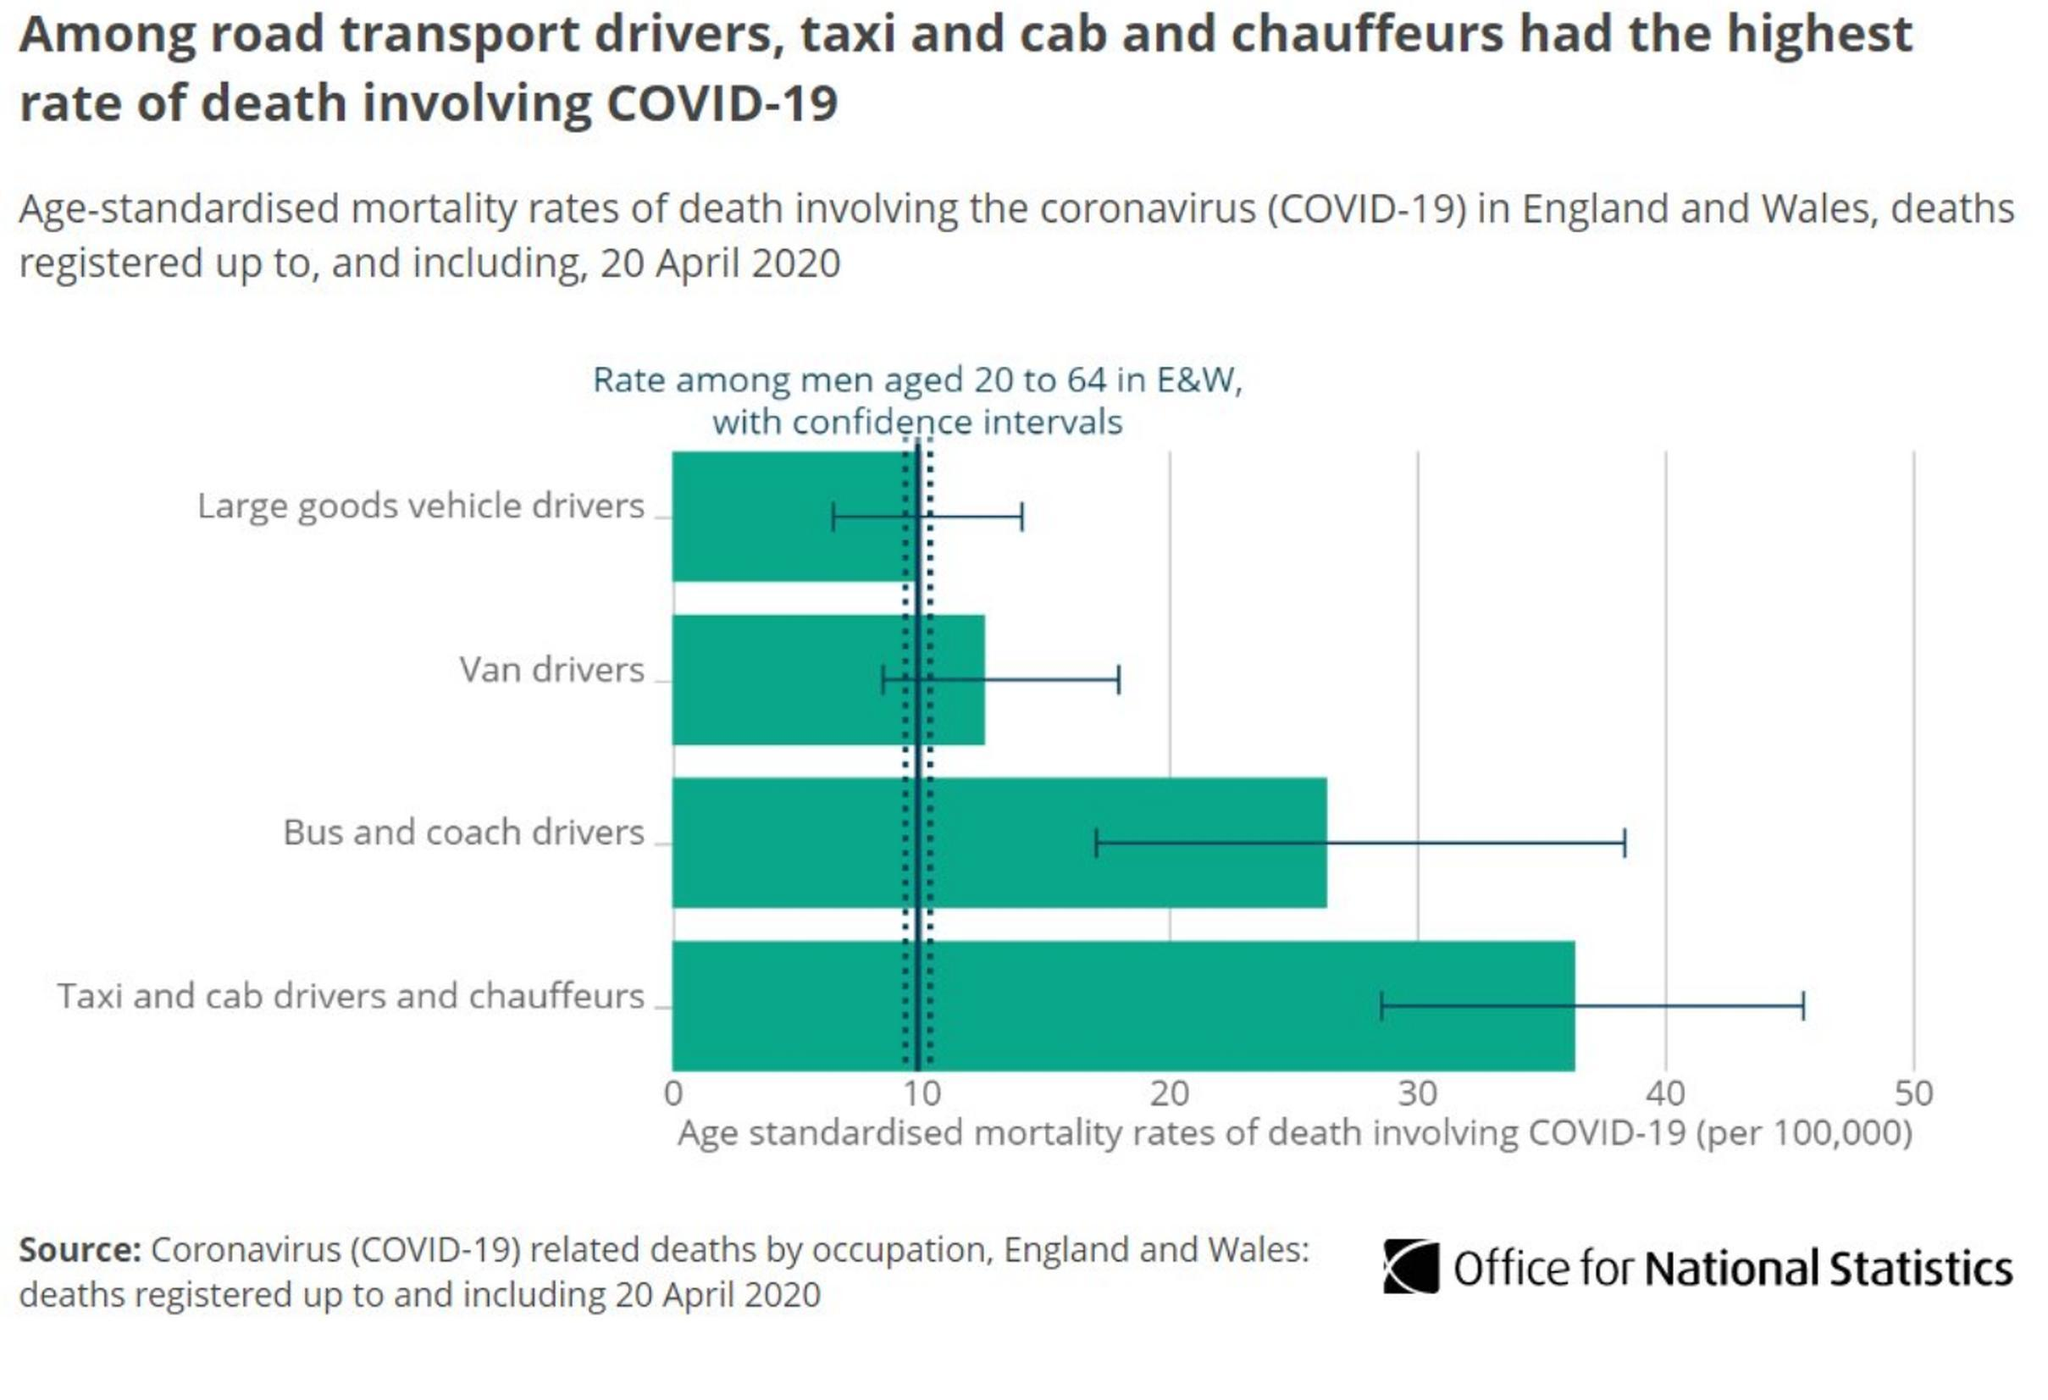Which transport drivers have death rate less than 20
Answer the question with a short phrase. van drivers, large good vehicle drivers Which transport drivers have death rate greater than 20 Bus and coach drivers, taxi and cab drivers and chauffeurs Which type of transport drivers have been least impacted Large goods vehicle drivers 